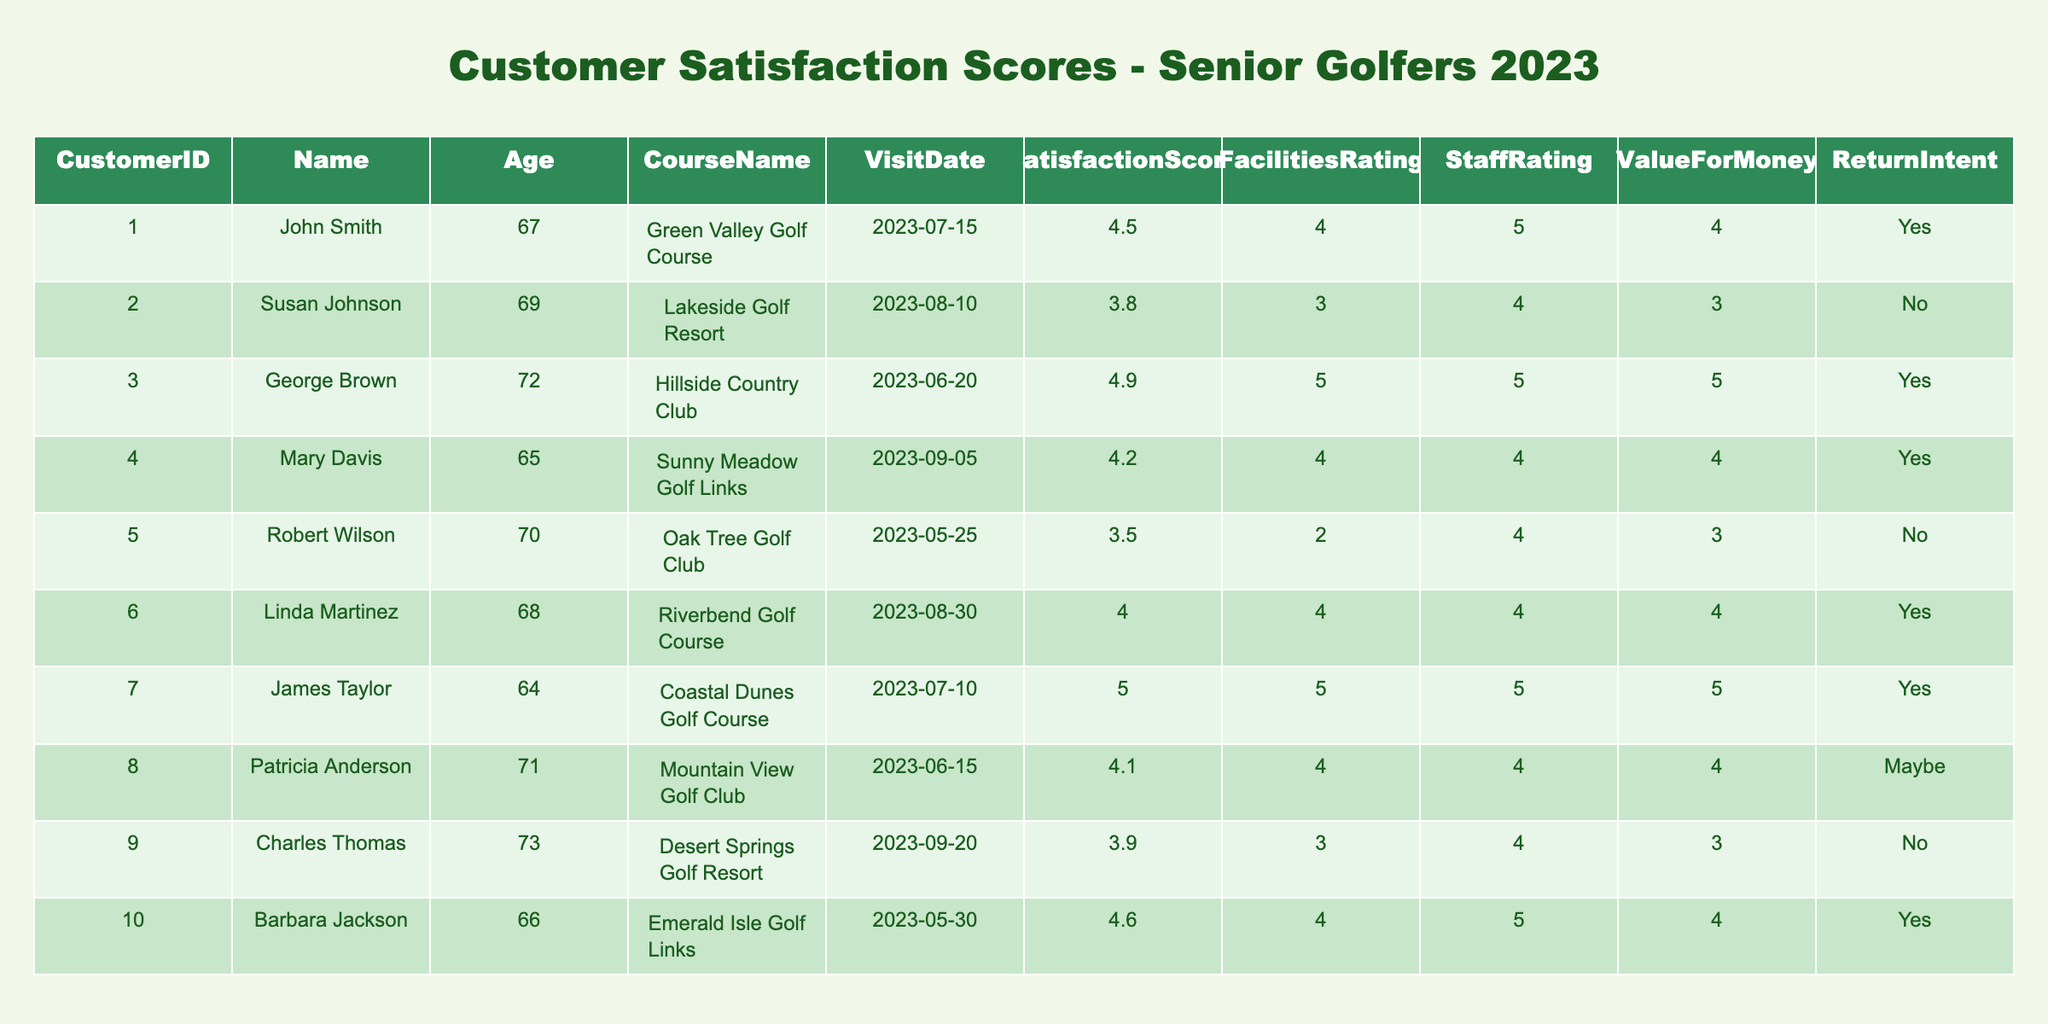What is the satisfaction score of George Brown? The table shows that George Brown has a satisfaction score of 4.9.
Answer: 4.9 How many golfers have a satisfaction score of 4 or higher? Counting the scores 4.5, 3.8, 4.9, 4.2, 4.0, 5.0, 4.1, 4.6, there are 7 golfers with a score of 4 or higher.
Answer: 7 What is the average satisfaction score of the senior golfers listed? The total satisfaction scores are 4.5 + 3.8 + 4.9 + 4.2 + 3.5 + 4.0 + 5.0 + 4.1 + 3.9 + 4.6 = 43.5. There are 10 golfers, so the average is 43.5 / 10 = 4.35.
Answer: 4.35 Which golf course had the highest satisfaction score? Comparing satisfaction scores, the highest score is 5.0 from Coastal Dunes Golf Course.
Answer: Coastal Dunes Golf Course How many golfers expressed an intention to return? The golfers with the return intent of "Yes" are John Smith, George Brown, Mary Davis, Linda Martinez, James Taylor, Barbara Jackson, totaling 6 golfers.
Answer: 6 Did any golfer rate the facilities as 2? Yes, Robert Wilson rated the facilities as 2.
Answer: Yes Is there a golfer who rated both facilities and staff as 5? Yes, George Brown rated both facilities and staff as 5.
Answer: Yes What is the satisfaction score of golfers who plan to return? For those who plan to return, their scores are 4.5, 4.9, 4.2, 4.0, 5.0, 4.6. The average is (4.5 + 4.9 + 4.2 + 4.0 + 5.0 + 4.6) / 6 = 4.55.
Answer: 4.55 Which golfer had the lowest facilities rating? Robert Wilson had the lowest facilities rating of 2.
Answer: Robert Wilson Are there any golfers who rated value for money as 5? Yes, James Taylor rated value for money as 5.
Answer: Yes 